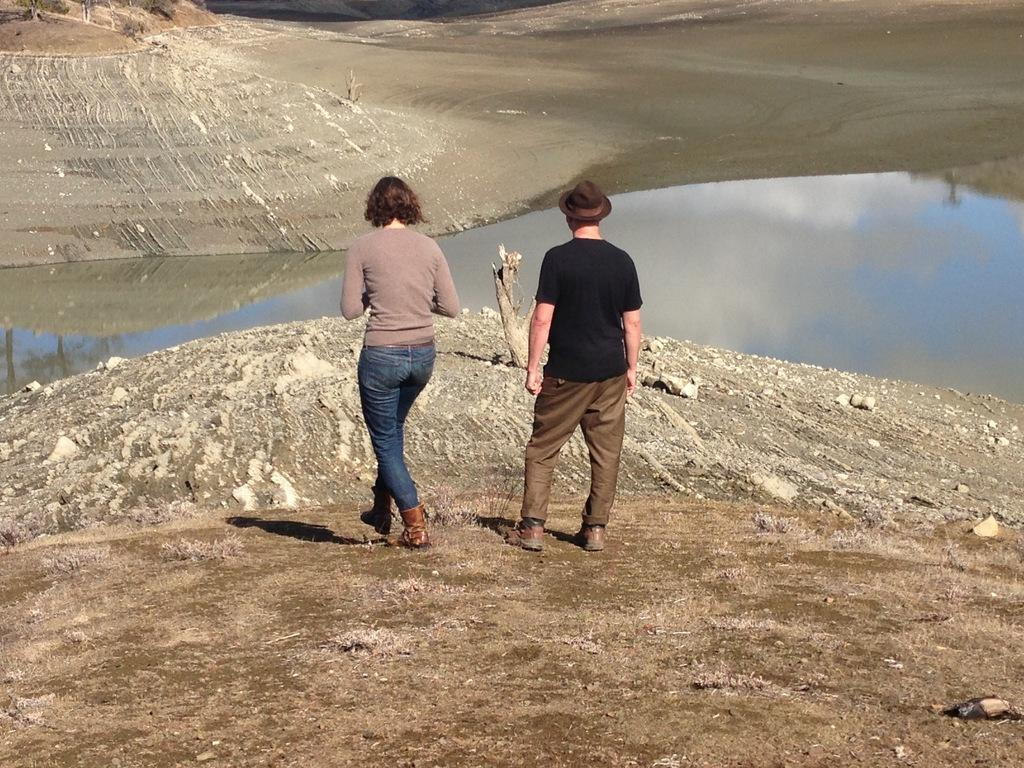How many people are in the image? There are two people in the image. Where are the people located in the image? The people are standing at the bank of a lake. What can be seen near the lake in the image? There is mud visible near the lake. What type of cushion is being used by the people to sit on the muddy ground? There is no cushion present in the image; the people are standing at the bank of the lake. 